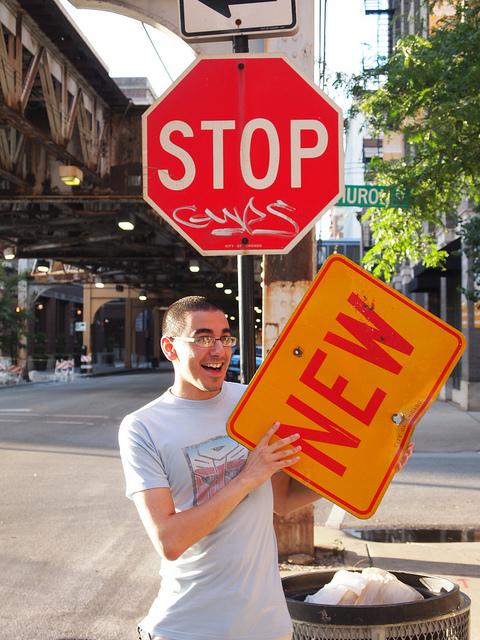What is the logo on the man's shirt?
Give a very brief answer. Transformers. Is the man happy?
Quick response, please. Yes. What does the sign he's holding say?
Concise answer only. New. 